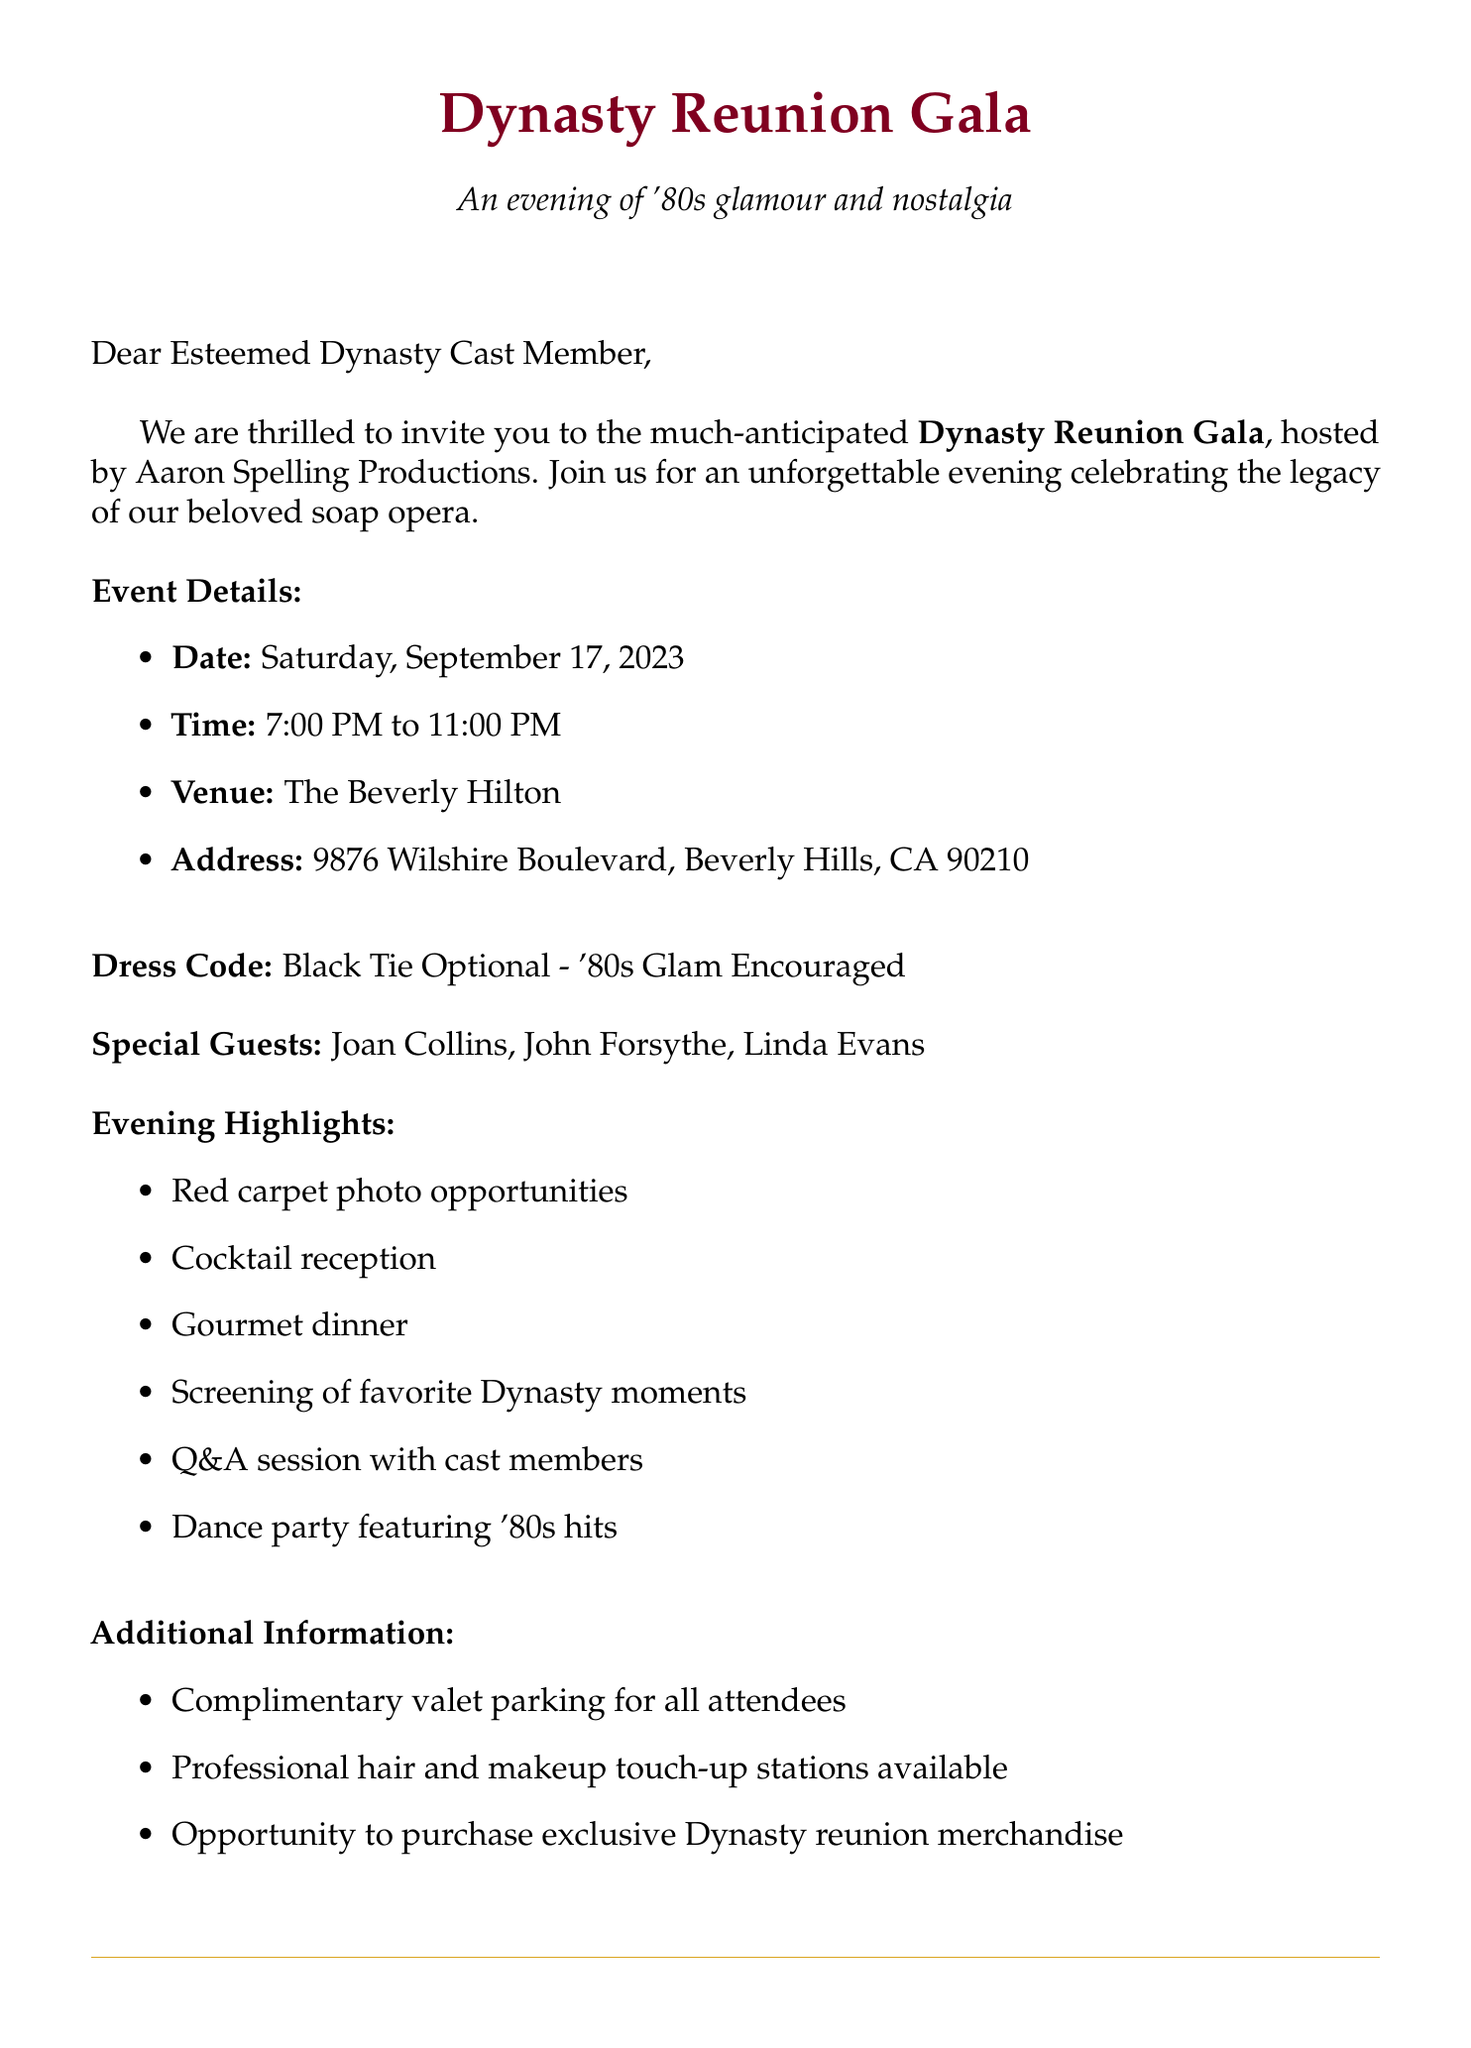What is the name of the event? The name of the event is mentioned in the opening of the invitation letter, which is "Dynasty Reunion Gala".
Answer: Dynasty Reunion Gala When is the event date? The event date is listed in the event details section of the document as "Saturday, September 17, 2023".
Answer: Saturday, September 17, 2023 What is the dress code for the event? The dress code is specified in the dress code section of the letter, which says "Black Tie Optional - '80s Glam Encouraged".
Answer: Black Tie Optional - '80s Glam Encouraged Who are the special guests mentioned? The special guests are listed in the document, specifically as notable cast members from the soap opera.
Answer: Joan Collins, John Forsythe, Linda Evans What activities will be featured during the event? The activities are outlined in the evening highlights section, detailing the planned events for the gala.
Answer: Red carpet photo opportunities, Cocktail reception, Gourmet dinner, Screening of favorite Dynasty moments, Q&A session with cast members, Dance party featuring '80s hits What is the RSVP deadline? The RSVP details section mentions the deadline for confirming attendance, which is stated clearly.
Answer: August 15, 2023 What hotel is suggested for accommodation? The accommodation section specifies the hotel where attendees can stay, as referenced for special rates.
Answer: The Beverly Hilton What is the special room rate at the hotel? The accommodation section provides the special nightly rate attendees can take advantage of, which is clearly defined.
Answer: $299 per night 